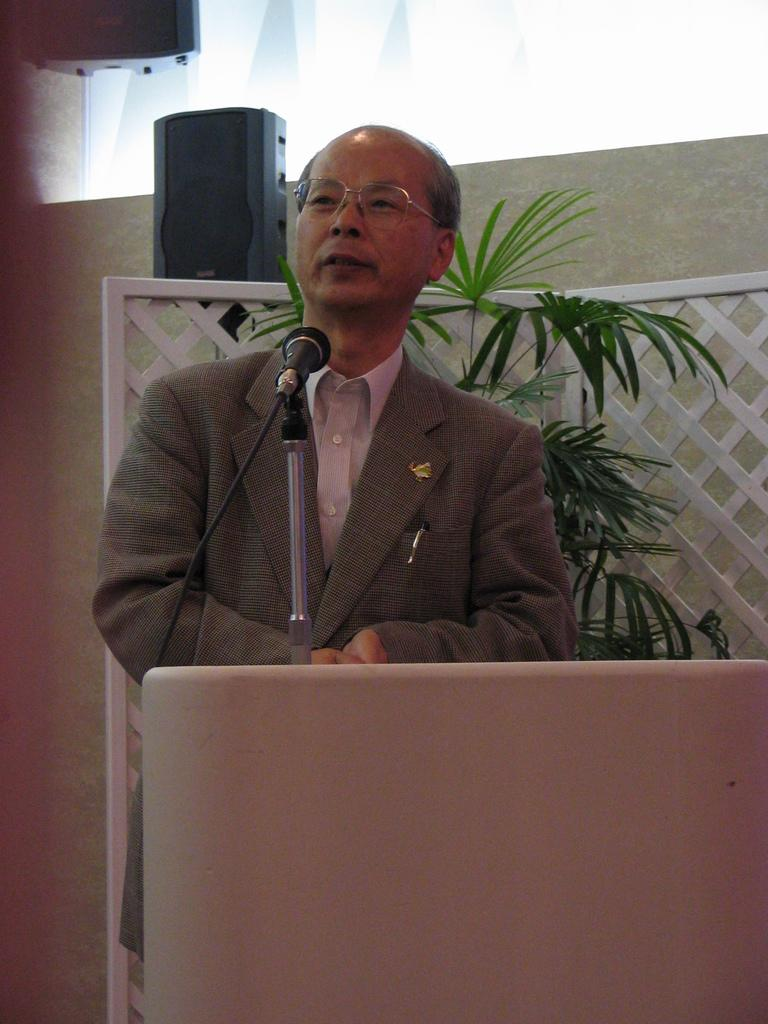Who is the main subject in the image? There is a man in the image. What is the man doing in the image? The man is standing in front of a microphone. What object is present on the stage with the man? There is a speech desk in the image. What can be seen in the background of the image? There is a plant and a speaker in the background of the image. What type of glue is being used to hold the plant in the image? There is no glue present in the image, and the plant is not being held in place by any adhesive. What kind of ray is emitted from the speaker in the image? There is no mention of any rays being emitted from the speaker in the image. 